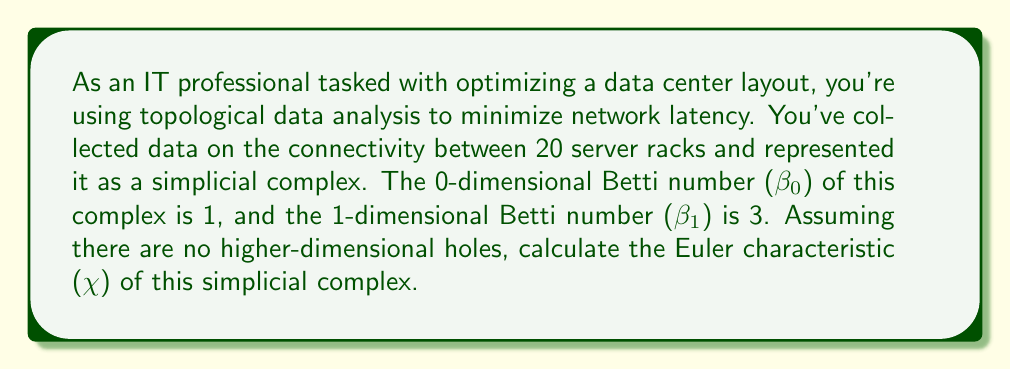Give your solution to this math problem. To solve this problem, we'll use the relationship between the Euler characteristic and Betti numbers in topological data analysis. The steps are as follows:

1) Recall the formula for the Euler characteristic in terms of Betti numbers:

   $$\chi = \sum_{i=0}^{\infty} (-1)^i \beta_i$$

   Where $\beta_i$ is the i-th Betti number.

2) We're given that:
   - $\beta_0 = 1$ (representing one connected component)
   - $\beta_1 = 3$ (representing three 1-dimensional holes or loops)
   - There are no higher-dimensional holes, so $\beta_i = 0$ for $i \geq 2$

3) Substituting these values into the formula:

   $$\chi = \beta_0 - \beta_1 + \beta_2 - \beta_3 + \cdots$$
   $$\chi = 1 - 3 + 0 - 0 + \cdots$$

4) Simplifying:

   $$\chi = 1 - 3 = -2$$

Thus, the Euler characteristic of the simplicial complex representing the data center layout is -2.

This negative Euler characteristic suggests a complex network topology with multiple loops, which could indicate redundant paths in the network layout. In the context of data center optimization, this might represent opportunities for load balancing or fault tolerance, but could also point to areas where simplification might reduce latency.
Answer: $\chi = -2$ 